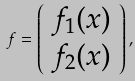<formula> <loc_0><loc_0><loc_500><loc_500>{ f } = \left ( \begin{array} { c } f _ { 1 } ( { x } ) \\ f _ { 2 } ( { x } ) \end{array} \right ) ,</formula> 